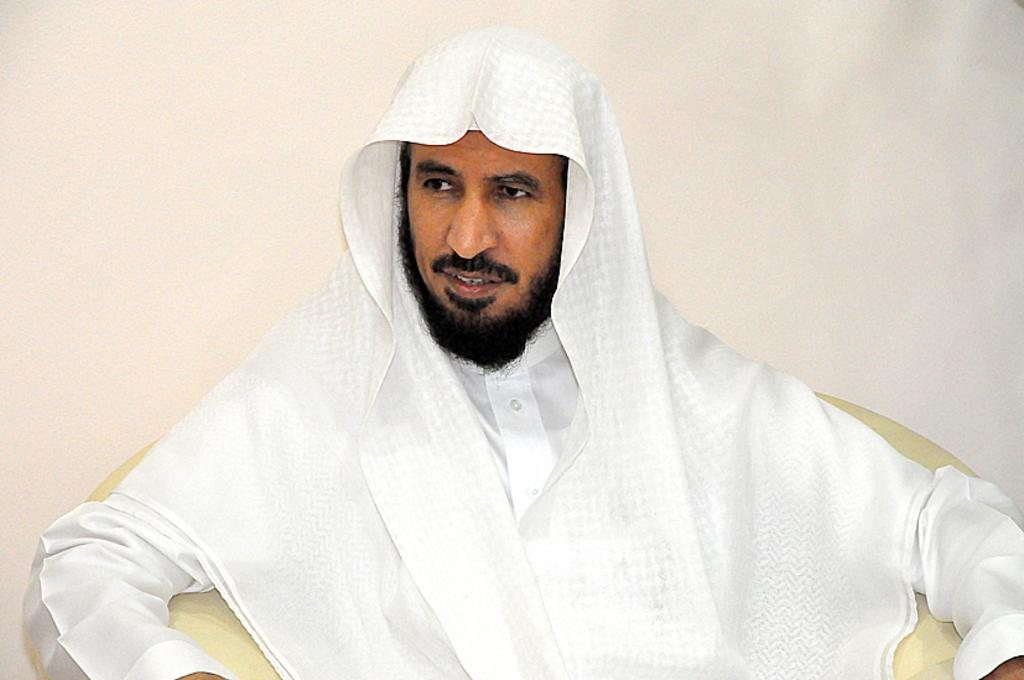Who is the main subject in the image? There is a man in the image. What is the man wearing? The man is wearing a white dress. What is the man doing in the image? The man is sitting on a sofa. Where is the man looking? The man is looking somewhere. What type of bottle can be seen in the man's hand in the image? There is no bottle present in the man's hand or in the image. 